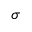Convert formula to latex. <formula><loc_0><loc_0><loc_500><loc_500>\sigma</formula> 